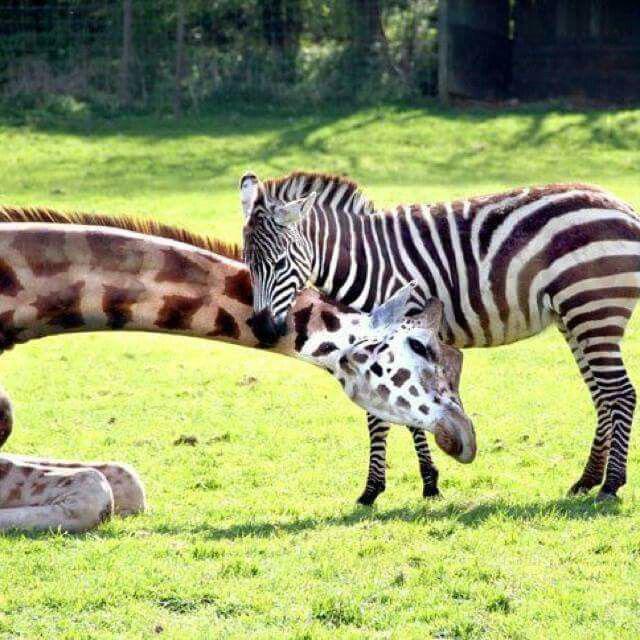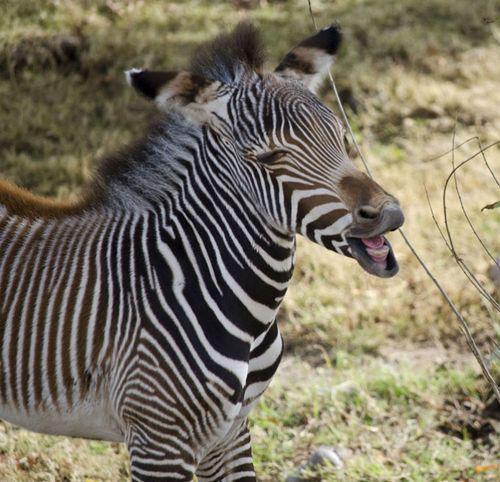The first image is the image on the left, the second image is the image on the right. Given the left and right images, does the statement "There are at least four zebras in total." hold true? Answer yes or no. No. The first image is the image on the left, the second image is the image on the right. Assess this claim about the two images: "All zebras are showing their teeth as if braying, and at least one image features two zebras side-by-side.". Correct or not? Answer yes or no. No. 